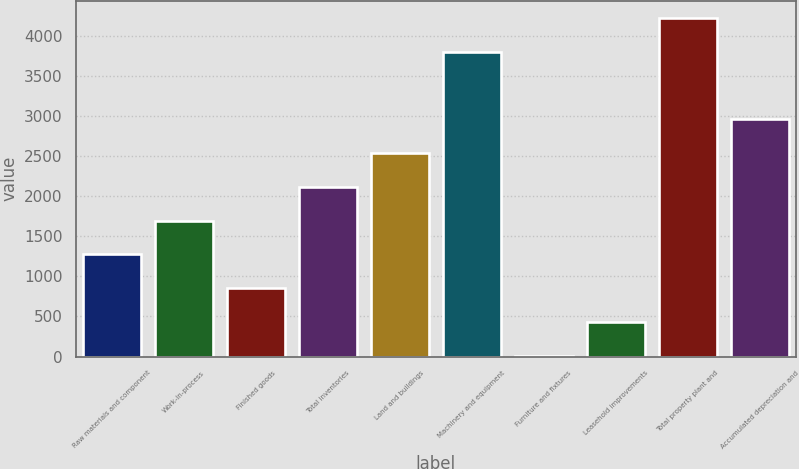<chart> <loc_0><loc_0><loc_500><loc_500><bar_chart><fcel>Raw materials and component<fcel>Work-in-process<fcel>Finished goods<fcel>Total inventories<fcel>Land and buildings<fcel>Machinery and equipment<fcel>Furniture and fixtures<fcel>Leasehold improvements<fcel>Total property plant and<fcel>Accumulated depreciation and<nl><fcel>1273.2<fcel>1694.6<fcel>851.8<fcel>2116<fcel>2537.4<fcel>3801.6<fcel>9<fcel>430.4<fcel>4223<fcel>2958.8<nl></chart> 